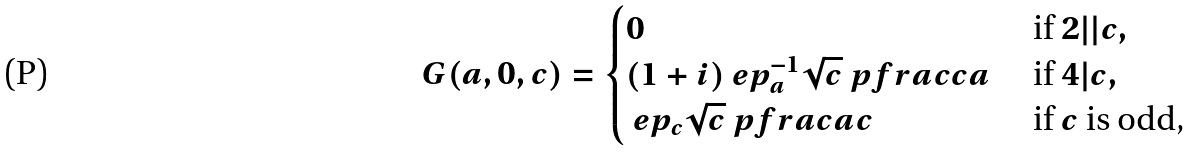<formula> <loc_0><loc_0><loc_500><loc_500>G ( a , 0 , c ) = \begin{cases} 0 & \text { if } 2 | | c , \\ ( 1 + i ) \ e p _ { a } ^ { - 1 } \sqrt { c } \ p f r a c c a & \text { if } 4 | c , \\ \ e p _ { c } \sqrt { c } \ p f r a c a c & \text { if $c$ is odd,} \end{cases}</formula> 